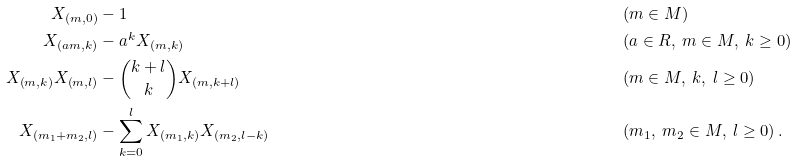<formula> <loc_0><loc_0><loc_500><loc_500>X _ { \left ( m , 0 \right ) } & - 1 & & \left ( m \in M \right ) \\ X _ { \left ( a m , k \right ) } & - a ^ { k } X _ { \left ( m , k \right ) } & & \left ( a \in R , \ m \in M , \ k \geq 0 \right ) \\ X _ { \left ( m , k \right ) } X _ { \left ( m , l \right ) } & - \binom { k + l } { k } X _ { \left ( m , k + l \right ) } & & \left ( m \in M , \ k , \ l \geq 0 \right ) \\ X _ { \left ( m _ { 1 } + m _ { 2 } , l \right ) } & - \sum _ { k = 0 } ^ { l } X _ { \left ( m _ { 1 } , k \right ) } X _ { \left ( m _ { 2 } , l - k \right ) } & & \left ( m _ { 1 } , \ m _ { 2 } \in M , \ l \geq 0 \right ) .</formula> 